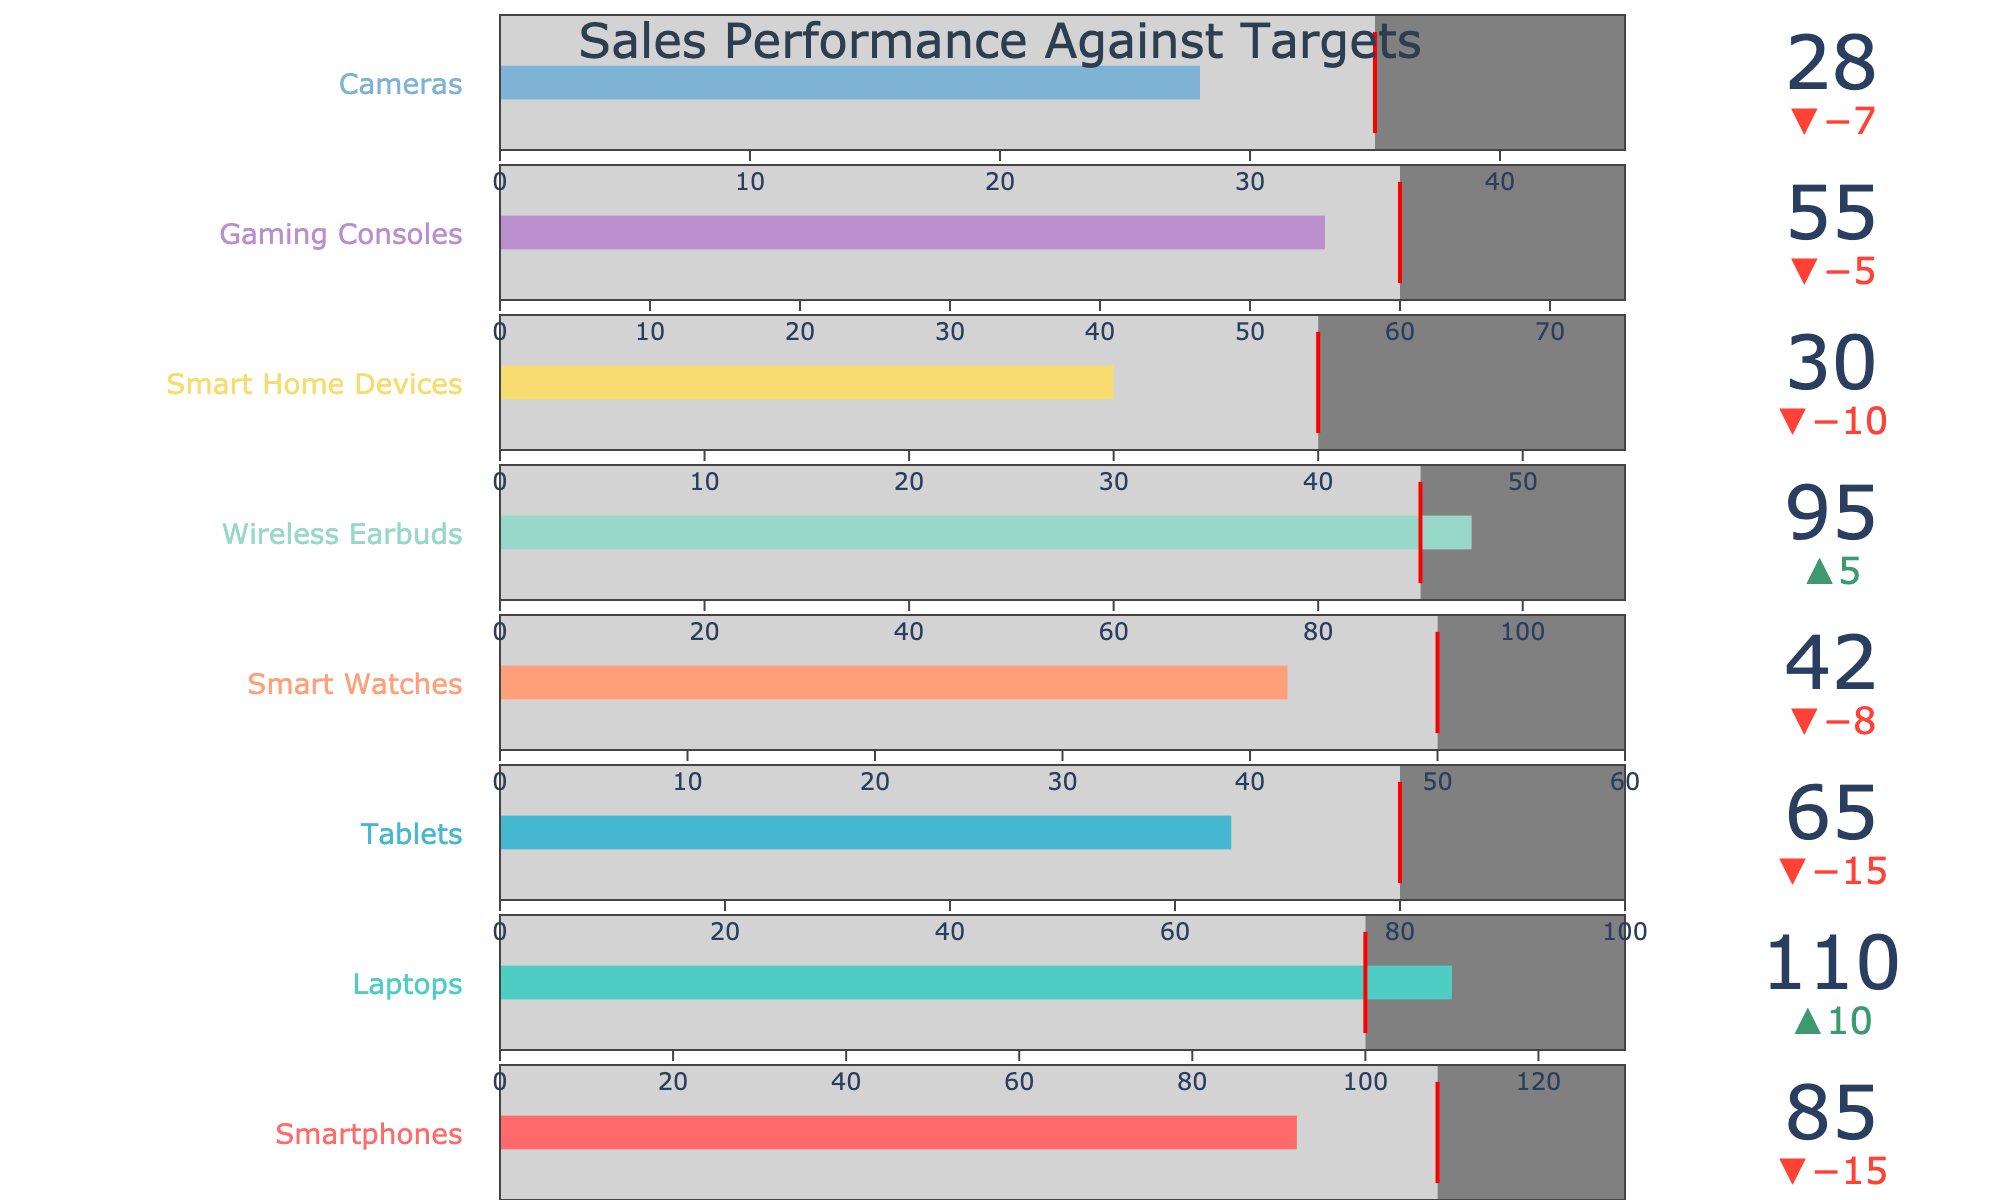What is the title of the chart? The title of the chart is usually placed at the top of the figure and it's labeled clearly.
Answer: Sales Performance Against Targets Which product line has the highest actual sales? By observing the actual sales values for each product line in the chart, we can identify which one is the highest.
Answer: Laptops Which product line failed to meet the target by the largest amount? Compare the difference between the actual sales and the target for each product line. The one with the largest negative difference is the biggest underperformer.
Answer: Smart Watches How many product lines have actual sales exceeding the targets? Count the product lines where the actual sales value is greater than the target value.
Answer: Four Which product line has the smallest maximum value range? Check the maximum value for each product line and identify the smallest one.
Answer: Cameras What is the precise difference between the actual sales and target for Wireless Earbuds? Subtract the target sales of Wireless Earbuds from the actual sales: 95 - 90 = 5.
Answer: 5 Are there any product lines where actual sales are exactly at the target value? Look for product lines where actual sales equals the target. There doesn't appear to be any such product line in this case.
Answer: No What's the combined actual sales of Smartphones and Tablets? Sum the actual sales values of Smartphones and Tablets: 85 + 65 = 150.
Answer: 150 Which product line has the most significant positive deviation from the target? Identify the product line with the greatest positive difference between actual sales and the target.
Answer: Wireless Earbuds What is the average target sales across all product lines? Sum the target values and divide by the number of product lines: (100 + 100 + 80 + 50 + 90 + 40 + 60 + 35) / 8 = 69.375.
Answer: 69.375 